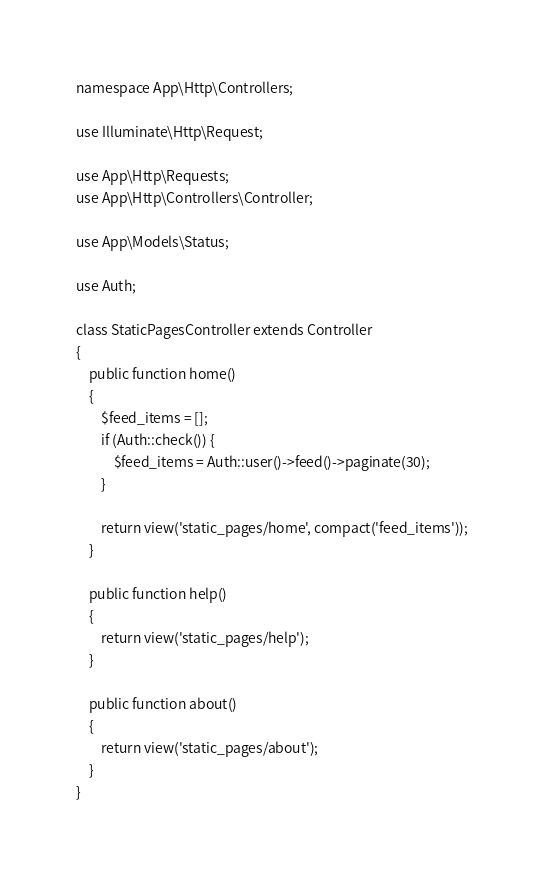Convert code to text. <code><loc_0><loc_0><loc_500><loc_500><_PHP_>namespace App\Http\Controllers;

use Illuminate\Http\Request;

use App\Http\Requests;
use App\Http\Controllers\Controller;

use App\Models\Status;

use Auth;

class StaticPagesController extends Controller
{
    public function home()
    {
        $feed_items = [];
        if (Auth::check()) {
            $feed_items = Auth::user()->feed()->paginate(30);
        }

        return view('static_pages/home', compact('feed_items'));
    }

    public function help()
    {
        return view('static_pages/help');
    }

    public function about()
    {
        return view('static_pages/about');
    }
}
</code> 